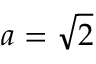<formula> <loc_0><loc_0><loc_500><loc_500>a = { \sqrt { 2 } }</formula> 